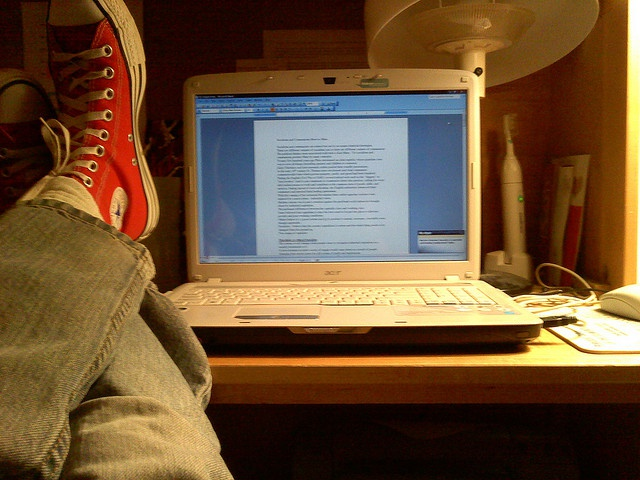Describe the objects in this image and their specific colors. I can see laptop in black, darkgray, khaki, gray, and tan tones, people in black, olive, and tan tones, toothbrush in black, olive, and maroon tones, and mouse in black, tan, beige, and olive tones in this image. 